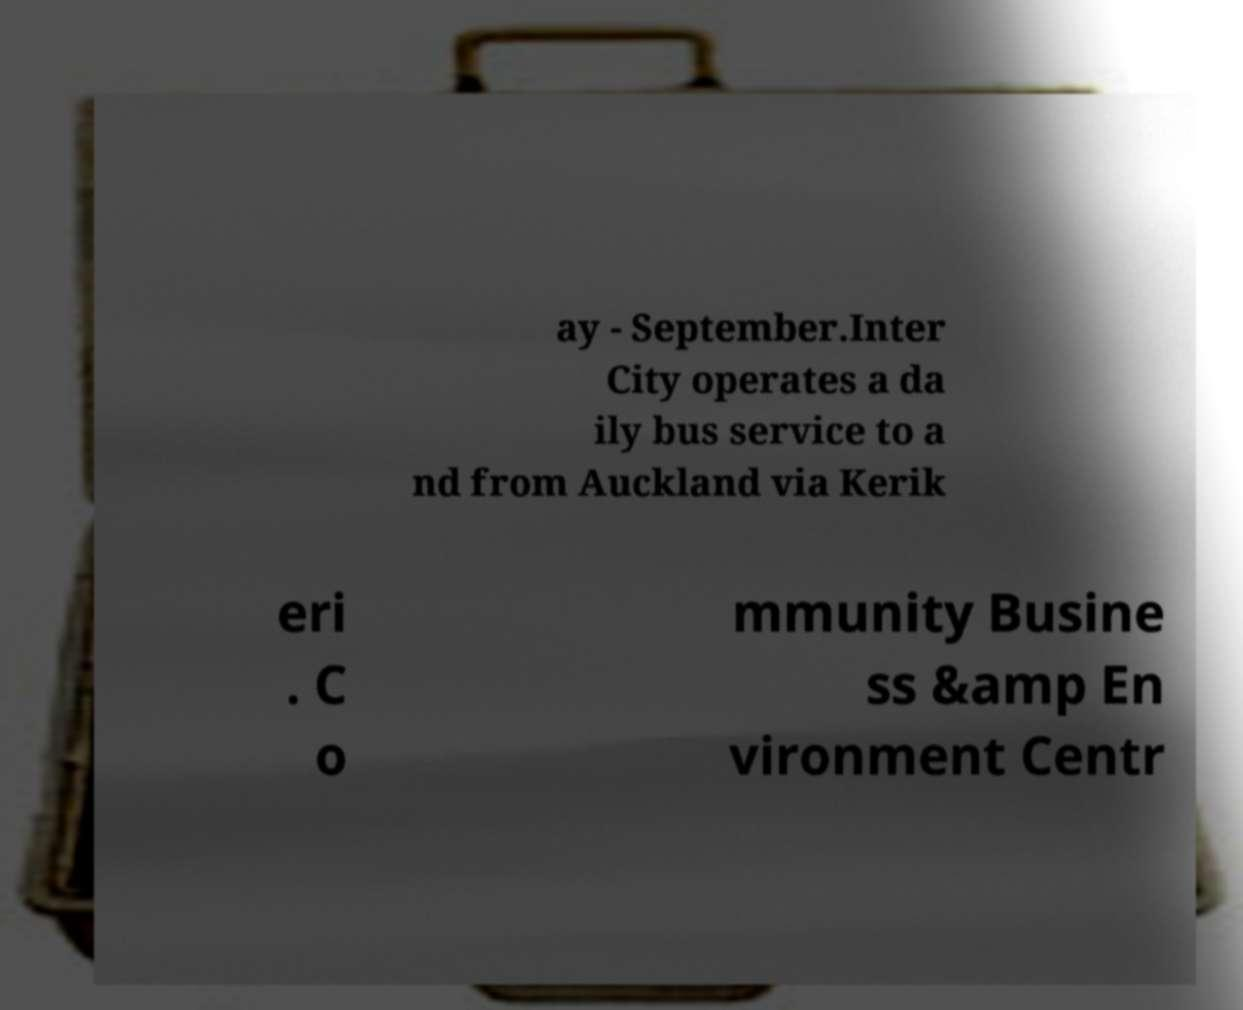What messages or text are displayed in this image? I need them in a readable, typed format. ay - September.Inter City operates a da ily bus service to a nd from Auckland via Kerik eri . C o mmunity Busine ss &amp En vironment Centr 